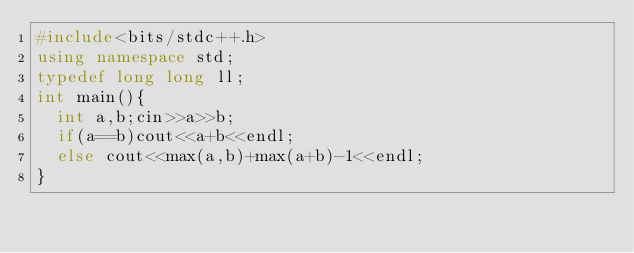Convert code to text. <code><loc_0><loc_0><loc_500><loc_500><_C++_>#include<bits/stdc++.h>
using namespace std;
typedef long long ll;
int main(){
  int a,b;cin>>a>>b;
  if(a==b)cout<<a+b<<endl;
  else cout<<max(a,b)+max(a+b)-1<<endl;
}</code> 